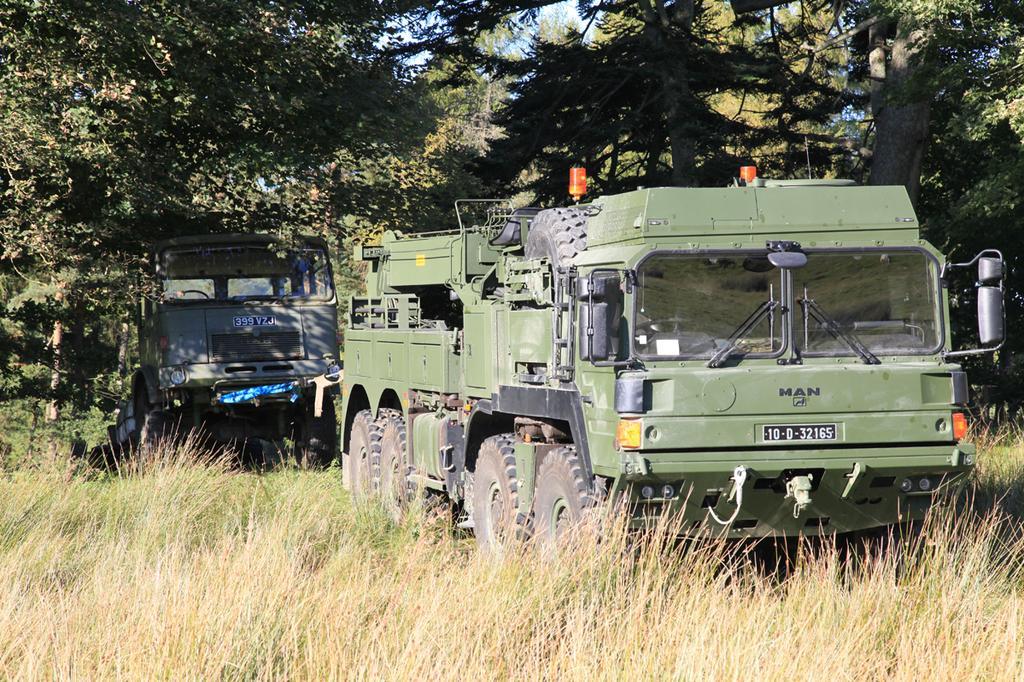Could you give a brief overview of what you see in this image? In the center of the image we can see two vehicles with number plates on it. In the background, we can see the sky, trees and grass. 